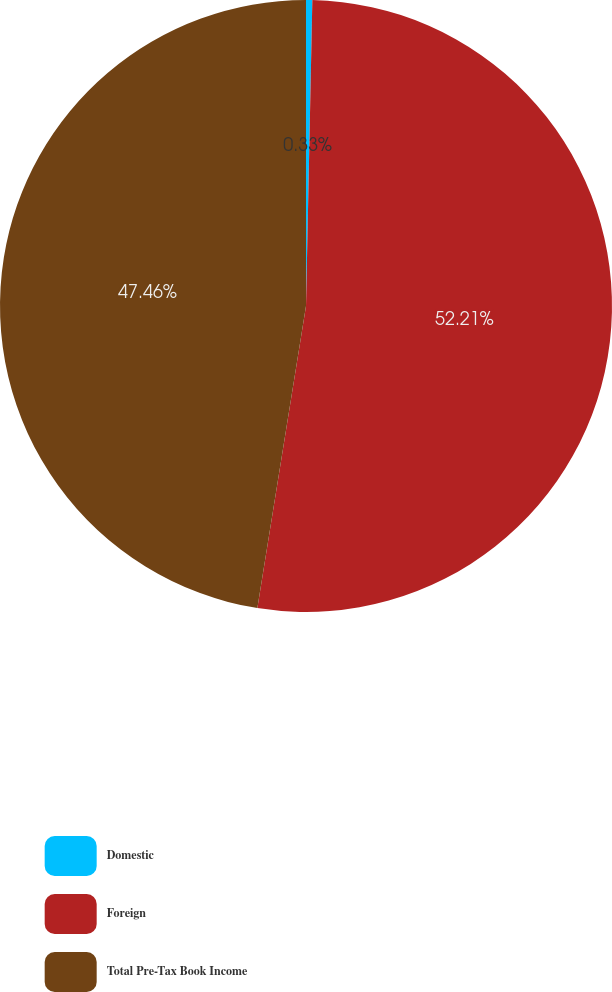Convert chart. <chart><loc_0><loc_0><loc_500><loc_500><pie_chart><fcel>Domestic<fcel>Foreign<fcel>Total Pre-Tax Book Income<nl><fcel>0.33%<fcel>52.21%<fcel>47.46%<nl></chart> 